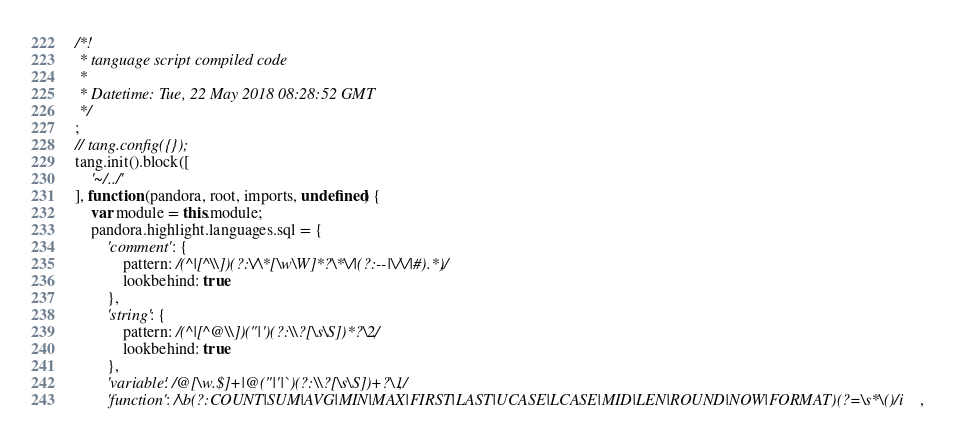Convert code to text. <code><loc_0><loc_0><loc_500><loc_500><_JavaScript_>/*!
 * tanguage script compiled code
 *
 * Datetime: Tue, 22 May 2018 08:28:52 GMT
 */
;
// tang.config({});
tang.init().block([
	'~/../'
], function (pandora, root, imports, undefined) {
	var module = this.module;
	pandora.highlight.languages.sql = {
		'comment': {
			pattern: /(^|[^\\])(?:\/\*[\w\W]*?\*\/|(?:--|\/\/|#).*)/,
			lookbehind: true
		},
		'string': {
			pattern: /(^|[^@\\])("|')(?:\\?[\s\S])*?\2/,
			lookbehind: true
		},
		'variable': /@[\w.$]+|@("|'|`)(?:\\?[\s\S])+?\1/,
		'function': /\b(?:COUNT|SUM|AVG|MIN|MAX|FIRST|LAST|UCASE|LCASE|MID|LEN|ROUND|NOW|FORMAT)(?=\s*\()/i,</code> 